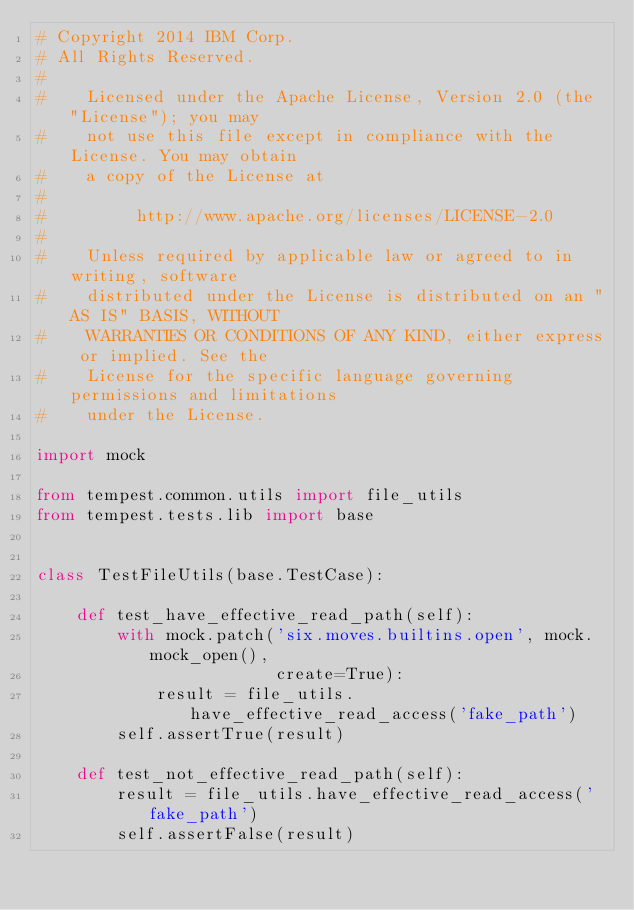Convert code to text. <code><loc_0><loc_0><loc_500><loc_500><_Python_># Copyright 2014 IBM Corp.
# All Rights Reserved.
#
#    Licensed under the Apache License, Version 2.0 (the "License"); you may
#    not use this file except in compliance with the License. You may obtain
#    a copy of the License at
#
#         http://www.apache.org/licenses/LICENSE-2.0
#
#    Unless required by applicable law or agreed to in writing, software
#    distributed under the License is distributed on an "AS IS" BASIS, WITHOUT
#    WARRANTIES OR CONDITIONS OF ANY KIND, either express or implied. See the
#    License for the specific language governing permissions and limitations
#    under the License.

import mock

from tempest.common.utils import file_utils
from tempest.tests.lib import base


class TestFileUtils(base.TestCase):

    def test_have_effective_read_path(self):
        with mock.patch('six.moves.builtins.open', mock.mock_open(),
                        create=True):
            result = file_utils.have_effective_read_access('fake_path')
        self.assertTrue(result)

    def test_not_effective_read_path(self):
        result = file_utils.have_effective_read_access('fake_path')
        self.assertFalse(result)
</code> 